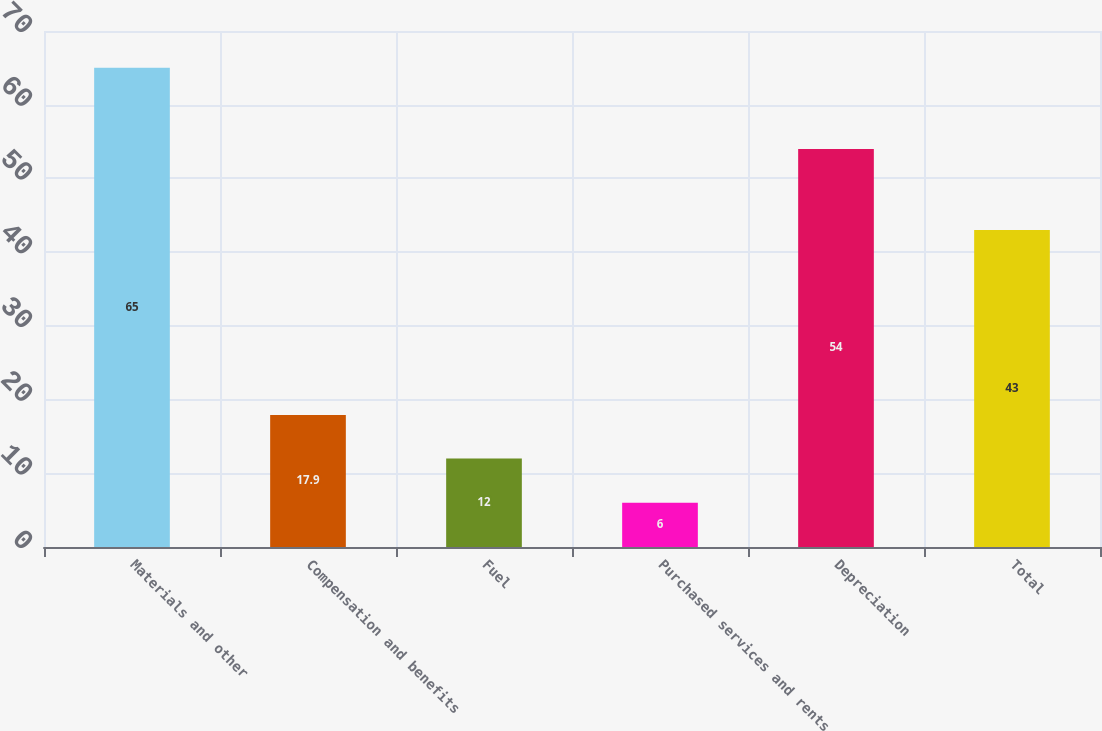<chart> <loc_0><loc_0><loc_500><loc_500><bar_chart><fcel>Materials and other<fcel>Compensation and benefits<fcel>Fuel<fcel>Purchased services and rents<fcel>Depreciation<fcel>Total<nl><fcel>65<fcel>17.9<fcel>12<fcel>6<fcel>54<fcel>43<nl></chart> 